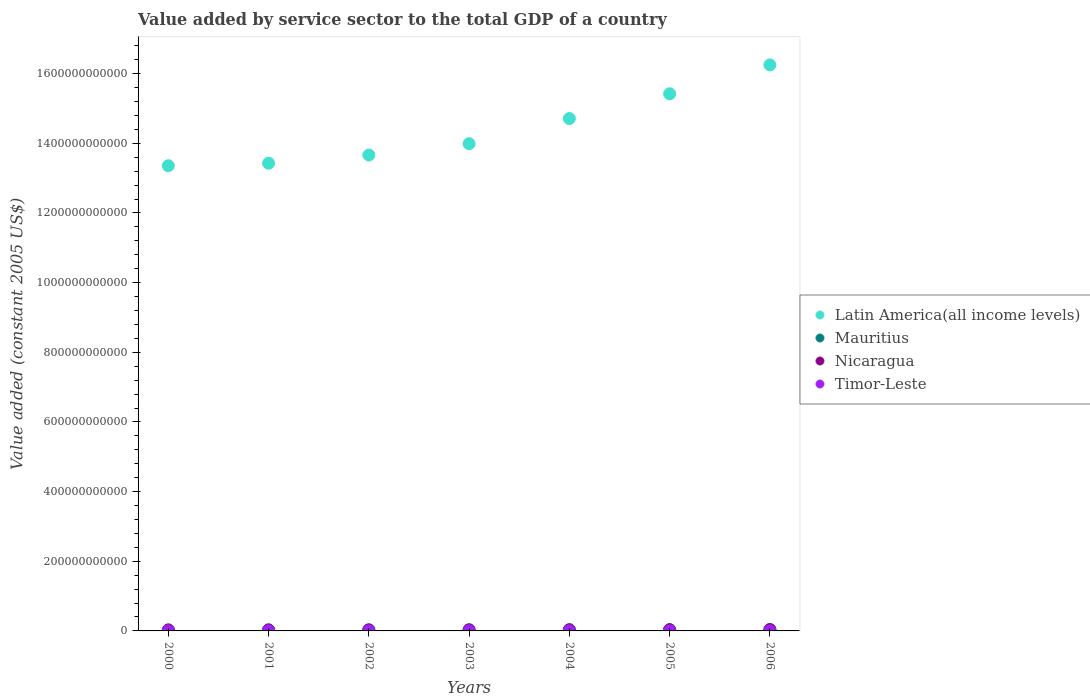How many different coloured dotlines are there?
Ensure brevity in your answer.  4. Is the number of dotlines equal to the number of legend labels?
Your response must be concise. Yes. What is the value added by service sector in Latin America(all income levels) in 2002?
Offer a terse response. 1.37e+12. Across all years, what is the maximum value added by service sector in Mauritius?
Keep it short and to the point. 3.86e+09. Across all years, what is the minimum value added by service sector in Nicaragua?
Offer a very short reply. 2.69e+09. In which year was the value added by service sector in Mauritius maximum?
Make the answer very short. 2006. What is the total value added by service sector in Latin America(all income levels) in the graph?
Your response must be concise. 1.01e+13. What is the difference between the value added by service sector in Mauritius in 2001 and that in 2005?
Ensure brevity in your answer.  -7.43e+08. What is the difference between the value added by service sector in Mauritius in 2003 and the value added by service sector in Latin America(all income levels) in 2005?
Your answer should be compact. -1.54e+12. What is the average value added by service sector in Nicaragua per year?
Make the answer very short. 3.01e+09. In the year 2001, what is the difference between the value added by service sector in Mauritius and value added by service sector in Timor-Leste?
Your answer should be very brief. 2.61e+09. What is the ratio of the value added by service sector in Nicaragua in 2004 to that in 2005?
Ensure brevity in your answer.  0.96. What is the difference between the highest and the second highest value added by service sector in Mauritius?
Offer a very short reply. 2.06e+08. What is the difference between the highest and the lowest value added by service sector in Timor-Leste?
Your answer should be compact. 7.10e+07. In how many years, is the value added by service sector in Latin America(all income levels) greater than the average value added by service sector in Latin America(all income levels) taken over all years?
Your answer should be very brief. 3. Is it the case that in every year, the sum of the value added by service sector in Timor-Leste and value added by service sector in Mauritius  is greater than the sum of value added by service sector in Nicaragua and value added by service sector in Latin America(all income levels)?
Ensure brevity in your answer.  Yes. Is it the case that in every year, the sum of the value added by service sector in Nicaragua and value added by service sector in Mauritius  is greater than the value added by service sector in Timor-Leste?
Ensure brevity in your answer.  Yes. Does the value added by service sector in Latin America(all income levels) monotonically increase over the years?
Make the answer very short. Yes. Is the value added by service sector in Mauritius strictly greater than the value added by service sector in Latin America(all income levels) over the years?
Ensure brevity in your answer.  No. What is the difference between two consecutive major ticks on the Y-axis?
Keep it short and to the point. 2.00e+11. Are the values on the major ticks of Y-axis written in scientific E-notation?
Give a very brief answer. No. Does the graph contain grids?
Provide a short and direct response. No. Where does the legend appear in the graph?
Make the answer very short. Center right. How many legend labels are there?
Offer a terse response. 4. What is the title of the graph?
Provide a short and direct response. Value added by service sector to the total GDP of a country. What is the label or title of the X-axis?
Make the answer very short. Years. What is the label or title of the Y-axis?
Offer a terse response. Value added (constant 2005 US$). What is the Value added (constant 2005 US$) in Latin America(all income levels) in 2000?
Provide a short and direct response. 1.34e+12. What is the Value added (constant 2005 US$) of Mauritius in 2000?
Make the answer very short. 2.77e+09. What is the Value added (constant 2005 US$) of Nicaragua in 2000?
Your response must be concise. 2.69e+09. What is the Value added (constant 2005 US$) in Timor-Leste in 2000?
Offer a terse response. 2.26e+08. What is the Value added (constant 2005 US$) of Latin America(all income levels) in 2001?
Make the answer very short. 1.34e+12. What is the Value added (constant 2005 US$) of Mauritius in 2001?
Give a very brief answer. 2.91e+09. What is the Value added (constant 2005 US$) of Nicaragua in 2001?
Provide a succinct answer. 2.79e+09. What is the Value added (constant 2005 US$) in Timor-Leste in 2001?
Offer a terse response. 2.95e+08. What is the Value added (constant 2005 US$) of Latin America(all income levels) in 2002?
Make the answer very short. 1.37e+12. What is the Value added (constant 2005 US$) of Mauritius in 2002?
Offer a terse response. 3.08e+09. What is the Value added (constant 2005 US$) of Nicaragua in 2002?
Your answer should be very brief. 2.85e+09. What is the Value added (constant 2005 US$) in Timor-Leste in 2002?
Provide a short and direct response. 2.65e+08. What is the Value added (constant 2005 US$) in Latin America(all income levels) in 2003?
Your response must be concise. 1.40e+12. What is the Value added (constant 2005 US$) in Mauritius in 2003?
Ensure brevity in your answer.  3.22e+09. What is the Value added (constant 2005 US$) in Nicaragua in 2003?
Give a very brief answer. 2.95e+09. What is the Value added (constant 2005 US$) in Timor-Leste in 2003?
Ensure brevity in your answer.  2.63e+08. What is the Value added (constant 2005 US$) of Latin America(all income levels) in 2004?
Provide a short and direct response. 1.47e+12. What is the Value added (constant 2005 US$) in Mauritius in 2004?
Your response must be concise. 3.43e+09. What is the Value added (constant 2005 US$) of Nicaragua in 2004?
Offer a terse response. 3.03e+09. What is the Value added (constant 2005 US$) in Timor-Leste in 2004?
Give a very brief answer. 2.73e+08. What is the Value added (constant 2005 US$) of Latin America(all income levels) in 2005?
Give a very brief answer. 1.54e+12. What is the Value added (constant 2005 US$) of Mauritius in 2005?
Provide a succinct answer. 3.65e+09. What is the Value added (constant 2005 US$) of Nicaragua in 2005?
Give a very brief answer. 3.15e+09. What is the Value added (constant 2005 US$) in Timor-Leste in 2005?
Provide a succinct answer. 2.97e+08. What is the Value added (constant 2005 US$) in Latin America(all income levels) in 2006?
Your answer should be very brief. 1.63e+12. What is the Value added (constant 2005 US$) in Mauritius in 2006?
Provide a short and direct response. 3.86e+09. What is the Value added (constant 2005 US$) in Nicaragua in 2006?
Provide a succinct answer. 3.59e+09. What is the Value added (constant 2005 US$) in Timor-Leste in 2006?
Your response must be concise. 2.89e+08. Across all years, what is the maximum Value added (constant 2005 US$) in Latin America(all income levels)?
Provide a short and direct response. 1.63e+12. Across all years, what is the maximum Value added (constant 2005 US$) of Mauritius?
Give a very brief answer. 3.86e+09. Across all years, what is the maximum Value added (constant 2005 US$) in Nicaragua?
Your response must be concise. 3.59e+09. Across all years, what is the maximum Value added (constant 2005 US$) in Timor-Leste?
Give a very brief answer. 2.97e+08. Across all years, what is the minimum Value added (constant 2005 US$) in Latin America(all income levels)?
Make the answer very short. 1.34e+12. Across all years, what is the minimum Value added (constant 2005 US$) of Mauritius?
Offer a very short reply. 2.77e+09. Across all years, what is the minimum Value added (constant 2005 US$) of Nicaragua?
Make the answer very short. 2.69e+09. Across all years, what is the minimum Value added (constant 2005 US$) in Timor-Leste?
Your answer should be compact. 2.26e+08. What is the total Value added (constant 2005 US$) of Latin America(all income levels) in the graph?
Provide a succinct answer. 1.01e+13. What is the total Value added (constant 2005 US$) of Mauritius in the graph?
Offer a very short reply. 2.29e+1. What is the total Value added (constant 2005 US$) in Nicaragua in the graph?
Ensure brevity in your answer.  2.10e+1. What is the total Value added (constant 2005 US$) of Timor-Leste in the graph?
Your response must be concise. 1.91e+09. What is the difference between the Value added (constant 2005 US$) in Latin America(all income levels) in 2000 and that in 2001?
Keep it short and to the point. -7.32e+09. What is the difference between the Value added (constant 2005 US$) of Mauritius in 2000 and that in 2001?
Offer a terse response. -1.40e+08. What is the difference between the Value added (constant 2005 US$) in Nicaragua in 2000 and that in 2001?
Keep it short and to the point. -1.03e+08. What is the difference between the Value added (constant 2005 US$) of Timor-Leste in 2000 and that in 2001?
Ensure brevity in your answer.  -6.95e+07. What is the difference between the Value added (constant 2005 US$) in Latin America(all income levels) in 2000 and that in 2002?
Offer a terse response. -3.07e+1. What is the difference between the Value added (constant 2005 US$) in Mauritius in 2000 and that in 2002?
Ensure brevity in your answer.  -3.16e+08. What is the difference between the Value added (constant 2005 US$) in Nicaragua in 2000 and that in 2002?
Keep it short and to the point. -1.66e+08. What is the difference between the Value added (constant 2005 US$) in Timor-Leste in 2000 and that in 2002?
Your answer should be very brief. -3.89e+07. What is the difference between the Value added (constant 2005 US$) in Latin America(all income levels) in 2000 and that in 2003?
Your response must be concise. -6.33e+1. What is the difference between the Value added (constant 2005 US$) of Mauritius in 2000 and that in 2003?
Provide a succinct answer. -4.56e+08. What is the difference between the Value added (constant 2005 US$) of Nicaragua in 2000 and that in 2003?
Make the answer very short. -2.60e+08. What is the difference between the Value added (constant 2005 US$) in Timor-Leste in 2000 and that in 2003?
Keep it short and to the point. -3.66e+07. What is the difference between the Value added (constant 2005 US$) of Latin America(all income levels) in 2000 and that in 2004?
Offer a very short reply. -1.35e+11. What is the difference between the Value added (constant 2005 US$) in Mauritius in 2000 and that in 2004?
Your answer should be compact. -6.65e+08. What is the difference between the Value added (constant 2005 US$) in Nicaragua in 2000 and that in 2004?
Your answer should be compact. -3.43e+08. What is the difference between the Value added (constant 2005 US$) of Timor-Leste in 2000 and that in 2004?
Offer a very short reply. -4.66e+07. What is the difference between the Value added (constant 2005 US$) of Latin America(all income levels) in 2000 and that in 2005?
Provide a short and direct response. -2.06e+11. What is the difference between the Value added (constant 2005 US$) in Mauritius in 2000 and that in 2005?
Offer a terse response. -8.83e+08. What is the difference between the Value added (constant 2005 US$) in Nicaragua in 2000 and that in 2005?
Provide a short and direct response. -4.63e+08. What is the difference between the Value added (constant 2005 US$) of Timor-Leste in 2000 and that in 2005?
Your answer should be very brief. -7.10e+07. What is the difference between the Value added (constant 2005 US$) of Latin America(all income levels) in 2000 and that in 2006?
Offer a terse response. -2.90e+11. What is the difference between the Value added (constant 2005 US$) in Mauritius in 2000 and that in 2006?
Provide a succinct answer. -1.09e+09. What is the difference between the Value added (constant 2005 US$) in Nicaragua in 2000 and that in 2006?
Provide a short and direct response. -8.97e+08. What is the difference between the Value added (constant 2005 US$) in Timor-Leste in 2000 and that in 2006?
Ensure brevity in your answer.  -6.34e+07. What is the difference between the Value added (constant 2005 US$) of Latin America(all income levels) in 2001 and that in 2002?
Your response must be concise. -2.34e+1. What is the difference between the Value added (constant 2005 US$) in Mauritius in 2001 and that in 2002?
Ensure brevity in your answer.  -1.76e+08. What is the difference between the Value added (constant 2005 US$) of Nicaragua in 2001 and that in 2002?
Provide a short and direct response. -6.33e+07. What is the difference between the Value added (constant 2005 US$) in Timor-Leste in 2001 and that in 2002?
Make the answer very short. 3.05e+07. What is the difference between the Value added (constant 2005 US$) in Latin America(all income levels) in 2001 and that in 2003?
Your answer should be very brief. -5.60e+1. What is the difference between the Value added (constant 2005 US$) in Mauritius in 2001 and that in 2003?
Your response must be concise. -3.15e+08. What is the difference between the Value added (constant 2005 US$) of Nicaragua in 2001 and that in 2003?
Your response must be concise. -1.57e+08. What is the difference between the Value added (constant 2005 US$) in Timor-Leste in 2001 and that in 2003?
Make the answer very short. 3.28e+07. What is the difference between the Value added (constant 2005 US$) in Latin America(all income levels) in 2001 and that in 2004?
Your answer should be compact. -1.28e+11. What is the difference between the Value added (constant 2005 US$) in Mauritius in 2001 and that in 2004?
Ensure brevity in your answer.  -5.25e+08. What is the difference between the Value added (constant 2005 US$) in Nicaragua in 2001 and that in 2004?
Offer a terse response. -2.40e+08. What is the difference between the Value added (constant 2005 US$) of Timor-Leste in 2001 and that in 2004?
Your response must be concise. 2.29e+07. What is the difference between the Value added (constant 2005 US$) in Latin America(all income levels) in 2001 and that in 2005?
Keep it short and to the point. -1.99e+11. What is the difference between the Value added (constant 2005 US$) in Mauritius in 2001 and that in 2005?
Provide a short and direct response. -7.43e+08. What is the difference between the Value added (constant 2005 US$) in Nicaragua in 2001 and that in 2005?
Ensure brevity in your answer.  -3.61e+08. What is the difference between the Value added (constant 2005 US$) of Timor-Leste in 2001 and that in 2005?
Give a very brief answer. -1.53e+06. What is the difference between the Value added (constant 2005 US$) in Latin America(all income levels) in 2001 and that in 2006?
Give a very brief answer. -2.82e+11. What is the difference between the Value added (constant 2005 US$) of Mauritius in 2001 and that in 2006?
Your answer should be very brief. -9.49e+08. What is the difference between the Value added (constant 2005 US$) of Nicaragua in 2001 and that in 2006?
Give a very brief answer. -7.94e+08. What is the difference between the Value added (constant 2005 US$) in Timor-Leste in 2001 and that in 2006?
Give a very brief answer. 6.11e+06. What is the difference between the Value added (constant 2005 US$) of Latin America(all income levels) in 2002 and that in 2003?
Your answer should be very brief. -3.26e+1. What is the difference between the Value added (constant 2005 US$) in Mauritius in 2002 and that in 2003?
Keep it short and to the point. -1.40e+08. What is the difference between the Value added (constant 2005 US$) in Nicaragua in 2002 and that in 2003?
Give a very brief answer. -9.38e+07. What is the difference between the Value added (constant 2005 US$) in Timor-Leste in 2002 and that in 2003?
Provide a succinct answer. 2.29e+06. What is the difference between the Value added (constant 2005 US$) of Latin America(all income levels) in 2002 and that in 2004?
Your response must be concise. -1.05e+11. What is the difference between the Value added (constant 2005 US$) of Mauritius in 2002 and that in 2004?
Offer a terse response. -3.49e+08. What is the difference between the Value added (constant 2005 US$) of Nicaragua in 2002 and that in 2004?
Your answer should be very brief. -1.77e+08. What is the difference between the Value added (constant 2005 US$) in Timor-Leste in 2002 and that in 2004?
Offer a very short reply. -7.63e+06. What is the difference between the Value added (constant 2005 US$) of Latin America(all income levels) in 2002 and that in 2005?
Offer a terse response. -1.76e+11. What is the difference between the Value added (constant 2005 US$) in Mauritius in 2002 and that in 2005?
Offer a very short reply. -5.67e+08. What is the difference between the Value added (constant 2005 US$) of Nicaragua in 2002 and that in 2005?
Keep it short and to the point. -2.97e+08. What is the difference between the Value added (constant 2005 US$) in Timor-Leste in 2002 and that in 2005?
Your answer should be very brief. -3.21e+07. What is the difference between the Value added (constant 2005 US$) of Latin America(all income levels) in 2002 and that in 2006?
Keep it short and to the point. -2.59e+11. What is the difference between the Value added (constant 2005 US$) of Mauritius in 2002 and that in 2006?
Offer a very short reply. -7.73e+08. What is the difference between the Value added (constant 2005 US$) of Nicaragua in 2002 and that in 2006?
Provide a short and direct response. -7.31e+08. What is the difference between the Value added (constant 2005 US$) of Timor-Leste in 2002 and that in 2006?
Offer a terse response. -2.44e+07. What is the difference between the Value added (constant 2005 US$) in Latin America(all income levels) in 2003 and that in 2004?
Offer a terse response. -7.21e+1. What is the difference between the Value added (constant 2005 US$) in Mauritius in 2003 and that in 2004?
Provide a succinct answer. -2.09e+08. What is the difference between the Value added (constant 2005 US$) in Nicaragua in 2003 and that in 2004?
Your response must be concise. -8.30e+07. What is the difference between the Value added (constant 2005 US$) of Timor-Leste in 2003 and that in 2004?
Your answer should be compact. -9.93e+06. What is the difference between the Value added (constant 2005 US$) of Latin America(all income levels) in 2003 and that in 2005?
Give a very brief answer. -1.43e+11. What is the difference between the Value added (constant 2005 US$) of Mauritius in 2003 and that in 2005?
Keep it short and to the point. -4.27e+08. What is the difference between the Value added (constant 2005 US$) of Nicaragua in 2003 and that in 2005?
Provide a short and direct response. -2.04e+08. What is the difference between the Value added (constant 2005 US$) of Timor-Leste in 2003 and that in 2005?
Ensure brevity in your answer.  -3.44e+07. What is the difference between the Value added (constant 2005 US$) of Latin America(all income levels) in 2003 and that in 2006?
Make the answer very short. -2.26e+11. What is the difference between the Value added (constant 2005 US$) of Mauritius in 2003 and that in 2006?
Your answer should be very brief. -6.34e+08. What is the difference between the Value added (constant 2005 US$) of Nicaragua in 2003 and that in 2006?
Keep it short and to the point. -6.37e+08. What is the difference between the Value added (constant 2005 US$) in Timor-Leste in 2003 and that in 2006?
Make the answer very short. -2.67e+07. What is the difference between the Value added (constant 2005 US$) of Latin America(all income levels) in 2004 and that in 2005?
Provide a succinct answer. -7.10e+1. What is the difference between the Value added (constant 2005 US$) in Mauritius in 2004 and that in 2005?
Your answer should be very brief. -2.18e+08. What is the difference between the Value added (constant 2005 US$) of Nicaragua in 2004 and that in 2005?
Give a very brief answer. -1.21e+08. What is the difference between the Value added (constant 2005 US$) of Timor-Leste in 2004 and that in 2005?
Offer a very short reply. -2.44e+07. What is the difference between the Value added (constant 2005 US$) of Latin America(all income levels) in 2004 and that in 2006?
Offer a very short reply. -1.54e+11. What is the difference between the Value added (constant 2005 US$) of Mauritius in 2004 and that in 2006?
Provide a succinct answer. -4.24e+08. What is the difference between the Value added (constant 2005 US$) in Nicaragua in 2004 and that in 2006?
Make the answer very short. -5.54e+08. What is the difference between the Value added (constant 2005 US$) in Timor-Leste in 2004 and that in 2006?
Keep it short and to the point. -1.68e+07. What is the difference between the Value added (constant 2005 US$) in Latin America(all income levels) in 2005 and that in 2006?
Keep it short and to the point. -8.31e+1. What is the difference between the Value added (constant 2005 US$) in Mauritius in 2005 and that in 2006?
Ensure brevity in your answer.  -2.06e+08. What is the difference between the Value added (constant 2005 US$) of Nicaragua in 2005 and that in 2006?
Keep it short and to the point. -4.34e+08. What is the difference between the Value added (constant 2005 US$) in Timor-Leste in 2005 and that in 2006?
Provide a succinct answer. 7.63e+06. What is the difference between the Value added (constant 2005 US$) in Latin America(all income levels) in 2000 and the Value added (constant 2005 US$) in Mauritius in 2001?
Keep it short and to the point. 1.33e+12. What is the difference between the Value added (constant 2005 US$) in Latin America(all income levels) in 2000 and the Value added (constant 2005 US$) in Nicaragua in 2001?
Your answer should be compact. 1.33e+12. What is the difference between the Value added (constant 2005 US$) of Latin America(all income levels) in 2000 and the Value added (constant 2005 US$) of Timor-Leste in 2001?
Ensure brevity in your answer.  1.34e+12. What is the difference between the Value added (constant 2005 US$) of Mauritius in 2000 and the Value added (constant 2005 US$) of Nicaragua in 2001?
Make the answer very short. -2.42e+07. What is the difference between the Value added (constant 2005 US$) of Mauritius in 2000 and the Value added (constant 2005 US$) of Timor-Leste in 2001?
Keep it short and to the point. 2.47e+09. What is the difference between the Value added (constant 2005 US$) of Nicaragua in 2000 and the Value added (constant 2005 US$) of Timor-Leste in 2001?
Offer a very short reply. 2.39e+09. What is the difference between the Value added (constant 2005 US$) of Latin America(all income levels) in 2000 and the Value added (constant 2005 US$) of Mauritius in 2002?
Your answer should be very brief. 1.33e+12. What is the difference between the Value added (constant 2005 US$) in Latin America(all income levels) in 2000 and the Value added (constant 2005 US$) in Nicaragua in 2002?
Ensure brevity in your answer.  1.33e+12. What is the difference between the Value added (constant 2005 US$) of Latin America(all income levels) in 2000 and the Value added (constant 2005 US$) of Timor-Leste in 2002?
Keep it short and to the point. 1.34e+12. What is the difference between the Value added (constant 2005 US$) of Mauritius in 2000 and the Value added (constant 2005 US$) of Nicaragua in 2002?
Provide a succinct answer. -8.75e+07. What is the difference between the Value added (constant 2005 US$) in Mauritius in 2000 and the Value added (constant 2005 US$) in Timor-Leste in 2002?
Provide a short and direct response. 2.50e+09. What is the difference between the Value added (constant 2005 US$) in Nicaragua in 2000 and the Value added (constant 2005 US$) in Timor-Leste in 2002?
Give a very brief answer. 2.42e+09. What is the difference between the Value added (constant 2005 US$) in Latin America(all income levels) in 2000 and the Value added (constant 2005 US$) in Mauritius in 2003?
Make the answer very short. 1.33e+12. What is the difference between the Value added (constant 2005 US$) of Latin America(all income levels) in 2000 and the Value added (constant 2005 US$) of Nicaragua in 2003?
Provide a succinct answer. 1.33e+12. What is the difference between the Value added (constant 2005 US$) in Latin America(all income levels) in 2000 and the Value added (constant 2005 US$) in Timor-Leste in 2003?
Give a very brief answer. 1.34e+12. What is the difference between the Value added (constant 2005 US$) in Mauritius in 2000 and the Value added (constant 2005 US$) in Nicaragua in 2003?
Your answer should be very brief. -1.81e+08. What is the difference between the Value added (constant 2005 US$) in Mauritius in 2000 and the Value added (constant 2005 US$) in Timor-Leste in 2003?
Give a very brief answer. 2.50e+09. What is the difference between the Value added (constant 2005 US$) of Nicaragua in 2000 and the Value added (constant 2005 US$) of Timor-Leste in 2003?
Offer a very short reply. 2.43e+09. What is the difference between the Value added (constant 2005 US$) in Latin America(all income levels) in 2000 and the Value added (constant 2005 US$) in Mauritius in 2004?
Ensure brevity in your answer.  1.33e+12. What is the difference between the Value added (constant 2005 US$) in Latin America(all income levels) in 2000 and the Value added (constant 2005 US$) in Nicaragua in 2004?
Keep it short and to the point. 1.33e+12. What is the difference between the Value added (constant 2005 US$) in Latin America(all income levels) in 2000 and the Value added (constant 2005 US$) in Timor-Leste in 2004?
Your response must be concise. 1.34e+12. What is the difference between the Value added (constant 2005 US$) of Mauritius in 2000 and the Value added (constant 2005 US$) of Nicaragua in 2004?
Ensure brevity in your answer.  -2.64e+08. What is the difference between the Value added (constant 2005 US$) in Mauritius in 2000 and the Value added (constant 2005 US$) in Timor-Leste in 2004?
Ensure brevity in your answer.  2.49e+09. What is the difference between the Value added (constant 2005 US$) in Nicaragua in 2000 and the Value added (constant 2005 US$) in Timor-Leste in 2004?
Offer a very short reply. 2.42e+09. What is the difference between the Value added (constant 2005 US$) in Latin America(all income levels) in 2000 and the Value added (constant 2005 US$) in Mauritius in 2005?
Your response must be concise. 1.33e+12. What is the difference between the Value added (constant 2005 US$) in Latin America(all income levels) in 2000 and the Value added (constant 2005 US$) in Nicaragua in 2005?
Offer a terse response. 1.33e+12. What is the difference between the Value added (constant 2005 US$) of Latin America(all income levels) in 2000 and the Value added (constant 2005 US$) of Timor-Leste in 2005?
Keep it short and to the point. 1.34e+12. What is the difference between the Value added (constant 2005 US$) of Mauritius in 2000 and the Value added (constant 2005 US$) of Nicaragua in 2005?
Offer a terse response. -3.85e+08. What is the difference between the Value added (constant 2005 US$) in Mauritius in 2000 and the Value added (constant 2005 US$) in Timor-Leste in 2005?
Offer a very short reply. 2.47e+09. What is the difference between the Value added (constant 2005 US$) of Nicaragua in 2000 and the Value added (constant 2005 US$) of Timor-Leste in 2005?
Your answer should be very brief. 2.39e+09. What is the difference between the Value added (constant 2005 US$) in Latin America(all income levels) in 2000 and the Value added (constant 2005 US$) in Mauritius in 2006?
Provide a succinct answer. 1.33e+12. What is the difference between the Value added (constant 2005 US$) of Latin America(all income levels) in 2000 and the Value added (constant 2005 US$) of Nicaragua in 2006?
Your response must be concise. 1.33e+12. What is the difference between the Value added (constant 2005 US$) of Latin America(all income levels) in 2000 and the Value added (constant 2005 US$) of Timor-Leste in 2006?
Your response must be concise. 1.34e+12. What is the difference between the Value added (constant 2005 US$) of Mauritius in 2000 and the Value added (constant 2005 US$) of Nicaragua in 2006?
Your response must be concise. -8.18e+08. What is the difference between the Value added (constant 2005 US$) in Mauritius in 2000 and the Value added (constant 2005 US$) in Timor-Leste in 2006?
Offer a terse response. 2.48e+09. What is the difference between the Value added (constant 2005 US$) in Nicaragua in 2000 and the Value added (constant 2005 US$) in Timor-Leste in 2006?
Make the answer very short. 2.40e+09. What is the difference between the Value added (constant 2005 US$) of Latin America(all income levels) in 2001 and the Value added (constant 2005 US$) of Mauritius in 2002?
Provide a short and direct response. 1.34e+12. What is the difference between the Value added (constant 2005 US$) in Latin America(all income levels) in 2001 and the Value added (constant 2005 US$) in Nicaragua in 2002?
Offer a very short reply. 1.34e+12. What is the difference between the Value added (constant 2005 US$) of Latin America(all income levels) in 2001 and the Value added (constant 2005 US$) of Timor-Leste in 2002?
Give a very brief answer. 1.34e+12. What is the difference between the Value added (constant 2005 US$) in Mauritius in 2001 and the Value added (constant 2005 US$) in Nicaragua in 2002?
Your response must be concise. 5.27e+07. What is the difference between the Value added (constant 2005 US$) in Mauritius in 2001 and the Value added (constant 2005 US$) in Timor-Leste in 2002?
Your response must be concise. 2.64e+09. What is the difference between the Value added (constant 2005 US$) of Nicaragua in 2001 and the Value added (constant 2005 US$) of Timor-Leste in 2002?
Your answer should be compact. 2.53e+09. What is the difference between the Value added (constant 2005 US$) in Latin America(all income levels) in 2001 and the Value added (constant 2005 US$) in Mauritius in 2003?
Your answer should be compact. 1.34e+12. What is the difference between the Value added (constant 2005 US$) of Latin America(all income levels) in 2001 and the Value added (constant 2005 US$) of Nicaragua in 2003?
Make the answer very short. 1.34e+12. What is the difference between the Value added (constant 2005 US$) of Latin America(all income levels) in 2001 and the Value added (constant 2005 US$) of Timor-Leste in 2003?
Keep it short and to the point. 1.34e+12. What is the difference between the Value added (constant 2005 US$) in Mauritius in 2001 and the Value added (constant 2005 US$) in Nicaragua in 2003?
Your answer should be very brief. -4.11e+07. What is the difference between the Value added (constant 2005 US$) of Mauritius in 2001 and the Value added (constant 2005 US$) of Timor-Leste in 2003?
Give a very brief answer. 2.64e+09. What is the difference between the Value added (constant 2005 US$) in Nicaragua in 2001 and the Value added (constant 2005 US$) in Timor-Leste in 2003?
Offer a very short reply. 2.53e+09. What is the difference between the Value added (constant 2005 US$) in Latin America(all income levels) in 2001 and the Value added (constant 2005 US$) in Mauritius in 2004?
Keep it short and to the point. 1.34e+12. What is the difference between the Value added (constant 2005 US$) in Latin America(all income levels) in 2001 and the Value added (constant 2005 US$) in Nicaragua in 2004?
Provide a short and direct response. 1.34e+12. What is the difference between the Value added (constant 2005 US$) of Latin America(all income levels) in 2001 and the Value added (constant 2005 US$) of Timor-Leste in 2004?
Provide a succinct answer. 1.34e+12. What is the difference between the Value added (constant 2005 US$) of Mauritius in 2001 and the Value added (constant 2005 US$) of Nicaragua in 2004?
Your answer should be compact. -1.24e+08. What is the difference between the Value added (constant 2005 US$) in Mauritius in 2001 and the Value added (constant 2005 US$) in Timor-Leste in 2004?
Give a very brief answer. 2.63e+09. What is the difference between the Value added (constant 2005 US$) of Nicaragua in 2001 and the Value added (constant 2005 US$) of Timor-Leste in 2004?
Offer a terse response. 2.52e+09. What is the difference between the Value added (constant 2005 US$) of Latin America(all income levels) in 2001 and the Value added (constant 2005 US$) of Mauritius in 2005?
Ensure brevity in your answer.  1.34e+12. What is the difference between the Value added (constant 2005 US$) of Latin America(all income levels) in 2001 and the Value added (constant 2005 US$) of Nicaragua in 2005?
Provide a succinct answer. 1.34e+12. What is the difference between the Value added (constant 2005 US$) of Latin America(all income levels) in 2001 and the Value added (constant 2005 US$) of Timor-Leste in 2005?
Provide a succinct answer. 1.34e+12. What is the difference between the Value added (constant 2005 US$) of Mauritius in 2001 and the Value added (constant 2005 US$) of Nicaragua in 2005?
Give a very brief answer. -2.45e+08. What is the difference between the Value added (constant 2005 US$) of Mauritius in 2001 and the Value added (constant 2005 US$) of Timor-Leste in 2005?
Ensure brevity in your answer.  2.61e+09. What is the difference between the Value added (constant 2005 US$) of Nicaragua in 2001 and the Value added (constant 2005 US$) of Timor-Leste in 2005?
Make the answer very short. 2.49e+09. What is the difference between the Value added (constant 2005 US$) of Latin America(all income levels) in 2001 and the Value added (constant 2005 US$) of Mauritius in 2006?
Ensure brevity in your answer.  1.34e+12. What is the difference between the Value added (constant 2005 US$) of Latin America(all income levels) in 2001 and the Value added (constant 2005 US$) of Nicaragua in 2006?
Keep it short and to the point. 1.34e+12. What is the difference between the Value added (constant 2005 US$) of Latin America(all income levels) in 2001 and the Value added (constant 2005 US$) of Timor-Leste in 2006?
Your answer should be compact. 1.34e+12. What is the difference between the Value added (constant 2005 US$) of Mauritius in 2001 and the Value added (constant 2005 US$) of Nicaragua in 2006?
Make the answer very short. -6.78e+08. What is the difference between the Value added (constant 2005 US$) of Mauritius in 2001 and the Value added (constant 2005 US$) of Timor-Leste in 2006?
Offer a very short reply. 2.62e+09. What is the difference between the Value added (constant 2005 US$) of Nicaragua in 2001 and the Value added (constant 2005 US$) of Timor-Leste in 2006?
Offer a very short reply. 2.50e+09. What is the difference between the Value added (constant 2005 US$) of Latin America(all income levels) in 2002 and the Value added (constant 2005 US$) of Mauritius in 2003?
Offer a very short reply. 1.36e+12. What is the difference between the Value added (constant 2005 US$) of Latin America(all income levels) in 2002 and the Value added (constant 2005 US$) of Nicaragua in 2003?
Provide a succinct answer. 1.36e+12. What is the difference between the Value added (constant 2005 US$) of Latin America(all income levels) in 2002 and the Value added (constant 2005 US$) of Timor-Leste in 2003?
Your answer should be very brief. 1.37e+12. What is the difference between the Value added (constant 2005 US$) in Mauritius in 2002 and the Value added (constant 2005 US$) in Nicaragua in 2003?
Provide a succinct answer. 1.34e+08. What is the difference between the Value added (constant 2005 US$) in Mauritius in 2002 and the Value added (constant 2005 US$) in Timor-Leste in 2003?
Offer a very short reply. 2.82e+09. What is the difference between the Value added (constant 2005 US$) in Nicaragua in 2002 and the Value added (constant 2005 US$) in Timor-Leste in 2003?
Keep it short and to the point. 2.59e+09. What is the difference between the Value added (constant 2005 US$) of Latin America(all income levels) in 2002 and the Value added (constant 2005 US$) of Mauritius in 2004?
Ensure brevity in your answer.  1.36e+12. What is the difference between the Value added (constant 2005 US$) of Latin America(all income levels) in 2002 and the Value added (constant 2005 US$) of Nicaragua in 2004?
Offer a very short reply. 1.36e+12. What is the difference between the Value added (constant 2005 US$) of Latin America(all income levels) in 2002 and the Value added (constant 2005 US$) of Timor-Leste in 2004?
Offer a terse response. 1.37e+12. What is the difference between the Value added (constant 2005 US$) in Mauritius in 2002 and the Value added (constant 2005 US$) in Nicaragua in 2004?
Give a very brief answer. 5.14e+07. What is the difference between the Value added (constant 2005 US$) in Mauritius in 2002 and the Value added (constant 2005 US$) in Timor-Leste in 2004?
Your answer should be very brief. 2.81e+09. What is the difference between the Value added (constant 2005 US$) of Nicaragua in 2002 and the Value added (constant 2005 US$) of Timor-Leste in 2004?
Offer a terse response. 2.58e+09. What is the difference between the Value added (constant 2005 US$) of Latin America(all income levels) in 2002 and the Value added (constant 2005 US$) of Mauritius in 2005?
Keep it short and to the point. 1.36e+12. What is the difference between the Value added (constant 2005 US$) in Latin America(all income levels) in 2002 and the Value added (constant 2005 US$) in Nicaragua in 2005?
Provide a succinct answer. 1.36e+12. What is the difference between the Value added (constant 2005 US$) in Latin America(all income levels) in 2002 and the Value added (constant 2005 US$) in Timor-Leste in 2005?
Offer a very short reply. 1.37e+12. What is the difference between the Value added (constant 2005 US$) of Mauritius in 2002 and the Value added (constant 2005 US$) of Nicaragua in 2005?
Make the answer very short. -6.91e+07. What is the difference between the Value added (constant 2005 US$) in Mauritius in 2002 and the Value added (constant 2005 US$) in Timor-Leste in 2005?
Offer a very short reply. 2.79e+09. What is the difference between the Value added (constant 2005 US$) in Nicaragua in 2002 and the Value added (constant 2005 US$) in Timor-Leste in 2005?
Offer a terse response. 2.56e+09. What is the difference between the Value added (constant 2005 US$) in Latin America(all income levels) in 2002 and the Value added (constant 2005 US$) in Mauritius in 2006?
Your response must be concise. 1.36e+12. What is the difference between the Value added (constant 2005 US$) in Latin America(all income levels) in 2002 and the Value added (constant 2005 US$) in Nicaragua in 2006?
Keep it short and to the point. 1.36e+12. What is the difference between the Value added (constant 2005 US$) in Latin America(all income levels) in 2002 and the Value added (constant 2005 US$) in Timor-Leste in 2006?
Keep it short and to the point. 1.37e+12. What is the difference between the Value added (constant 2005 US$) in Mauritius in 2002 and the Value added (constant 2005 US$) in Nicaragua in 2006?
Provide a succinct answer. -5.03e+08. What is the difference between the Value added (constant 2005 US$) of Mauritius in 2002 and the Value added (constant 2005 US$) of Timor-Leste in 2006?
Keep it short and to the point. 2.79e+09. What is the difference between the Value added (constant 2005 US$) of Nicaragua in 2002 and the Value added (constant 2005 US$) of Timor-Leste in 2006?
Offer a terse response. 2.56e+09. What is the difference between the Value added (constant 2005 US$) in Latin America(all income levels) in 2003 and the Value added (constant 2005 US$) in Mauritius in 2004?
Ensure brevity in your answer.  1.40e+12. What is the difference between the Value added (constant 2005 US$) of Latin America(all income levels) in 2003 and the Value added (constant 2005 US$) of Nicaragua in 2004?
Offer a very short reply. 1.40e+12. What is the difference between the Value added (constant 2005 US$) of Latin America(all income levels) in 2003 and the Value added (constant 2005 US$) of Timor-Leste in 2004?
Offer a terse response. 1.40e+12. What is the difference between the Value added (constant 2005 US$) of Mauritius in 2003 and the Value added (constant 2005 US$) of Nicaragua in 2004?
Your answer should be very brief. 1.91e+08. What is the difference between the Value added (constant 2005 US$) in Mauritius in 2003 and the Value added (constant 2005 US$) in Timor-Leste in 2004?
Offer a terse response. 2.95e+09. What is the difference between the Value added (constant 2005 US$) in Nicaragua in 2003 and the Value added (constant 2005 US$) in Timor-Leste in 2004?
Keep it short and to the point. 2.68e+09. What is the difference between the Value added (constant 2005 US$) in Latin America(all income levels) in 2003 and the Value added (constant 2005 US$) in Mauritius in 2005?
Offer a very short reply. 1.40e+12. What is the difference between the Value added (constant 2005 US$) of Latin America(all income levels) in 2003 and the Value added (constant 2005 US$) of Nicaragua in 2005?
Provide a succinct answer. 1.40e+12. What is the difference between the Value added (constant 2005 US$) of Latin America(all income levels) in 2003 and the Value added (constant 2005 US$) of Timor-Leste in 2005?
Your answer should be compact. 1.40e+12. What is the difference between the Value added (constant 2005 US$) of Mauritius in 2003 and the Value added (constant 2005 US$) of Nicaragua in 2005?
Your answer should be very brief. 7.08e+07. What is the difference between the Value added (constant 2005 US$) in Mauritius in 2003 and the Value added (constant 2005 US$) in Timor-Leste in 2005?
Keep it short and to the point. 2.93e+09. What is the difference between the Value added (constant 2005 US$) in Nicaragua in 2003 and the Value added (constant 2005 US$) in Timor-Leste in 2005?
Make the answer very short. 2.65e+09. What is the difference between the Value added (constant 2005 US$) of Latin America(all income levels) in 2003 and the Value added (constant 2005 US$) of Mauritius in 2006?
Provide a succinct answer. 1.40e+12. What is the difference between the Value added (constant 2005 US$) of Latin America(all income levels) in 2003 and the Value added (constant 2005 US$) of Nicaragua in 2006?
Keep it short and to the point. 1.40e+12. What is the difference between the Value added (constant 2005 US$) in Latin America(all income levels) in 2003 and the Value added (constant 2005 US$) in Timor-Leste in 2006?
Ensure brevity in your answer.  1.40e+12. What is the difference between the Value added (constant 2005 US$) in Mauritius in 2003 and the Value added (constant 2005 US$) in Nicaragua in 2006?
Ensure brevity in your answer.  -3.63e+08. What is the difference between the Value added (constant 2005 US$) of Mauritius in 2003 and the Value added (constant 2005 US$) of Timor-Leste in 2006?
Give a very brief answer. 2.93e+09. What is the difference between the Value added (constant 2005 US$) in Nicaragua in 2003 and the Value added (constant 2005 US$) in Timor-Leste in 2006?
Provide a short and direct response. 2.66e+09. What is the difference between the Value added (constant 2005 US$) in Latin America(all income levels) in 2004 and the Value added (constant 2005 US$) in Mauritius in 2005?
Make the answer very short. 1.47e+12. What is the difference between the Value added (constant 2005 US$) of Latin America(all income levels) in 2004 and the Value added (constant 2005 US$) of Nicaragua in 2005?
Your answer should be very brief. 1.47e+12. What is the difference between the Value added (constant 2005 US$) of Latin America(all income levels) in 2004 and the Value added (constant 2005 US$) of Timor-Leste in 2005?
Make the answer very short. 1.47e+12. What is the difference between the Value added (constant 2005 US$) of Mauritius in 2004 and the Value added (constant 2005 US$) of Nicaragua in 2005?
Your response must be concise. 2.80e+08. What is the difference between the Value added (constant 2005 US$) in Mauritius in 2004 and the Value added (constant 2005 US$) in Timor-Leste in 2005?
Provide a short and direct response. 3.13e+09. What is the difference between the Value added (constant 2005 US$) of Nicaragua in 2004 and the Value added (constant 2005 US$) of Timor-Leste in 2005?
Your answer should be very brief. 2.73e+09. What is the difference between the Value added (constant 2005 US$) of Latin America(all income levels) in 2004 and the Value added (constant 2005 US$) of Mauritius in 2006?
Ensure brevity in your answer.  1.47e+12. What is the difference between the Value added (constant 2005 US$) in Latin America(all income levels) in 2004 and the Value added (constant 2005 US$) in Nicaragua in 2006?
Your answer should be very brief. 1.47e+12. What is the difference between the Value added (constant 2005 US$) of Latin America(all income levels) in 2004 and the Value added (constant 2005 US$) of Timor-Leste in 2006?
Offer a terse response. 1.47e+12. What is the difference between the Value added (constant 2005 US$) in Mauritius in 2004 and the Value added (constant 2005 US$) in Nicaragua in 2006?
Offer a terse response. -1.53e+08. What is the difference between the Value added (constant 2005 US$) of Mauritius in 2004 and the Value added (constant 2005 US$) of Timor-Leste in 2006?
Your answer should be compact. 3.14e+09. What is the difference between the Value added (constant 2005 US$) in Nicaragua in 2004 and the Value added (constant 2005 US$) in Timor-Leste in 2006?
Provide a succinct answer. 2.74e+09. What is the difference between the Value added (constant 2005 US$) of Latin America(all income levels) in 2005 and the Value added (constant 2005 US$) of Mauritius in 2006?
Give a very brief answer. 1.54e+12. What is the difference between the Value added (constant 2005 US$) in Latin America(all income levels) in 2005 and the Value added (constant 2005 US$) in Nicaragua in 2006?
Offer a very short reply. 1.54e+12. What is the difference between the Value added (constant 2005 US$) of Latin America(all income levels) in 2005 and the Value added (constant 2005 US$) of Timor-Leste in 2006?
Your answer should be compact. 1.54e+12. What is the difference between the Value added (constant 2005 US$) in Mauritius in 2005 and the Value added (constant 2005 US$) in Nicaragua in 2006?
Offer a very short reply. 6.44e+07. What is the difference between the Value added (constant 2005 US$) in Mauritius in 2005 and the Value added (constant 2005 US$) in Timor-Leste in 2006?
Make the answer very short. 3.36e+09. What is the difference between the Value added (constant 2005 US$) in Nicaragua in 2005 and the Value added (constant 2005 US$) in Timor-Leste in 2006?
Ensure brevity in your answer.  2.86e+09. What is the average Value added (constant 2005 US$) of Latin America(all income levels) per year?
Your response must be concise. 1.44e+12. What is the average Value added (constant 2005 US$) of Mauritius per year?
Offer a terse response. 3.27e+09. What is the average Value added (constant 2005 US$) in Nicaragua per year?
Keep it short and to the point. 3.01e+09. What is the average Value added (constant 2005 US$) of Timor-Leste per year?
Make the answer very short. 2.73e+08. In the year 2000, what is the difference between the Value added (constant 2005 US$) of Latin America(all income levels) and Value added (constant 2005 US$) of Mauritius?
Give a very brief answer. 1.33e+12. In the year 2000, what is the difference between the Value added (constant 2005 US$) in Latin America(all income levels) and Value added (constant 2005 US$) in Nicaragua?
Keep it short and to the point. 1.33e+12. In the year 2000, what is the difference between the Value added (constant 2005 US$) of Latin America(all income levels) and Value added (constant 2005 US$) of Timor-Leste?
Offer a terse response. 1.34e+12. In the year 2000, what is the difference between the Value added (constant 2005 US$) of Mauritius and Value added (constant 2005 US$) of Nicaragua?
Your answer should be very brief. 7.87e+07. In the year 2000, what is the difference between the Value added (constant 2005 US$) in Mauritius and Value added (constant 2005 US$) in Timor-Leste?
Ensure brevity in your answer.  2.54e+09. In the year 2000, what is the difference between the Value added (constant 2005 US$) in Nicaragua and Value added (constant 2005 US$) in Timor-Leste?
Keep it short and to the point. 2.46e+09. In the year 2001, what is the difference between the Value added (constant 2005 US$) of Latin America(all income levels) and Value added (constant 2005 US$) of Mauritius?
Provide a short and direct response. 1.34e+12. In the year 2001, what is the difference between the Value added (constant 2005 US$) of Latin America(all income levels) and Value added (constant 2005 US$) of Nicaragua?
Offer a terse response. 1.34e+12. In the year 2001, what is the difference between the Value added (constant 2005 US$) in Latin America(all income levels) and Value added (constant 2005 US$) in Timor-Leste?
Provide a succinct answer. 1.34e+12. In the year 2001, what is the difference between the Value added (constant 2005 US$) in Mauritius and Value added (constant 2005 US$) in Nicaragua?
Your answer should be compact. 1.16e+08. In the year 2001, what is the difference between the Value added (constant 2005 US$) in Mauritius and Value added (constant 2005 US$) in Timor-Leste?
Keep it short and to the point. 2.61e+09. In the year 2001, what is the difference between the Value added (constant 2005 US$) in Nicaragua and Value added (constant 2005 US$) in Timor-Leste?
Offer a terse response. 2.50e+09. In the year 2002, what is the difference between the Value added (constant 2005 US$) of Latin America(all income levels) and Value added (constant 2005 US$) of Mauritius?
Your response must be concise. 1.36e+12. In the year 2002, what is the difference between the Value added (constant 2005 US$) of Latin America(all income levels) and Value added (constant 2005 US$) of Nicaragua?
Make the answer very short. 1.36e+12. In the year 2002, what is the difference between the Value added (constant 2005 US$) in Latin America(all income levels) and Value added (constant 2005 US$) in Timor-Leste?
Ensure brevity in your answer.  1.37e+12. In the year 2002, what is the difference between the Value added (constant 2005 US$) of Mauritius and Value added (constant 2005 US$) of Nicaragua?
Make the answer very short. 2.28e+08. In the year 2002, what is the difference between the Value added (constant 2005 US$) in Mauritius and Value added (constant 2005 US$) in Timor-Leste?
Keep it short and to the point. 2.82e+09. In the year 2002, what is the difference between the Value added (constant 2005 US$) in Nicaragua and Value added (constant 2005 US$) in Timor-Leste?
Your answer should be compact. 2.59e+09. In the year 2003, what is the difference between the Value added (constant 2005 US$) in Latin America(all income levels) and Value added (constant 2005 US$) in Mauritius?
Offer a very short reply. 1.40e+12. In the year 2003, what is the difference between the Value added (constant 2005 US$) of Latin America(all income levels) and Value added (constant 2005 US$) of Nicaragua?
Provide a short and direct response. 1.40e+12. In the year 2003, what is the difference between the Value added (constant 2005 US$) in Latin America(all income levels) and Value added (constant 2005 US$) in Timor-Leste?
Keep it short and to the point. 1.40e+12. In the year 2003, what is the difference between the Value added (constant 2005 US$) in Mauritius and Value added (constant 2005 US$) in Nicaragua?
Make the answer very short. 2.74e+08. In the year 2003, what is the difference between the Value added (constant 2005 US$) in Mauritius and Value added (constant 2005 US$) in Timor-Leste?
Offer a terse response. 2.96e+09. In the year 2003, what is the difference between the Value added (constant 2005 US$) in Nicaragua and Value added (constant 2005 US$) in Timor-Leste?
Give a very brief answer. 2.69e+09. In the year 2004, what is the difference between the Value added (constant 2005 US$) of Latin America(all income levels) and Value added (constant 2005 US$) of Mauritius?
Your response must be concise. 1.47e+12. In the year 2004, what is the difference between the Value added (constant 2005 US$) in Latin America(all income levels) and Value added (constant 2005 US$) in Nicaragua?
Offer a very short reply. 1.47e+12. In the year 2004, what is the difference between the Value added (constant 2005 US$) of Latin America(all income levels) and Value added (constant 2005 US$) of Timor-Leste?
Your response must be concise. 1.47e+12. In the year 2004, what is the difference between the Value added (constant 2005 US$) in Mauritius and Value added (constant 2005 US$) in Nicaragua?
Your answer should be very brief. 4.01e+08. In the year 2004, what is the difference between the Value added (constant 2005 US$) of Mauritius and Value added (constant 2005 US$) of Timor-Leste?
Keep it short and to the point. 3.16e+09. In the year 2004, what is the difference between the Value added (constant 2005 US$) in Nicaragua and Value added (constant 2005 US$) in Timor-Leste?
Provide a short and direct response. 2.76e+09. In the year 2005, what is the difference between the Value added (constant 2005 US$) of Latin America(all income levels) and Value added (constant 2005 US$) of Mauritius?
Your response must be concise. 1.54e+12. In the year 2005, what is the difference between the Value added (constant 2005 US$) in Latin America(all income levels) and Value added (constant 2005 US$) in Nicaragua?
Your answer should be compact. 1.54e+12. In the year 2005, what is the difference between the Value added (constant 2005 US$) of Latin America(all income levels) and Value added (constant 2005 US$) of Timor-Leste?
Give a very brief answer. 1.54e+12. In the year 2005, what is the difference between the Value added (constant 2005 US$) of Mauritius and Value added (constant 2005 US$) of Nicaragua?
Your answer should be compact. 4.98e+08. In the year 2005, what is the difference between the Value added (constant 2005 US$) of Mauritius and Value added (constant 2005 US$) of Timor-Leste?
Provide a short and direct response. 3.35e+09. In the year 2005, what is the difference between the Value added (constant 2005 US$) in Nicaragua and Value added (constant 2005 US$) in Timor-Leste?
Your answer should be compact. 2.85e+09. In the year 2006, what is the difference between the Value added (constant 2005 US$) in Latin America(all income levels) and Value added (constant 2005 US$) in Mauritius?
Offer a terse response. 1.62e+12. In the year 2006, what is the difference between the Value added (constant 2005 US$) of Latin America(all income levels) and Value added (constant 2005 US$) of Nicaragua?
Make the answer very short. 1.62e+12. In the year 2006, what is the difference between the Value added (constant 2005 US$) in Latin America(all income levels) and Value added (constant 2005 US$) in Timor-Leste?
Provide a short and direct response. 1.62e+12. In the year 2006, what is the difference between the Value added (constant 2005 US$) in Mauritius and Value added (constant 2005 US$) in Nicaragua?
Your answer should be very brief. 2.71e+08. In the year 2006, what is the difference between the Value added (constant 2005 US$) of Mauritius and Value added (constant 2005 US$) of Timor-Leste?
Ensure brevity in your answer.  3.57e+09. In the year 2006, what is the difference between the Value added (constant 2005 US$) in Nicaragua and Value added (constant 2005 US$) in Timor-Leste?
Offer a very short reply. 3.30e+09. What is the ratio of the Value added (constant 2005 US$) of Mauritius in 2000 to that in 2001?
Give a very brief answer. 0.95. What is the ratio of the Value added (constant 2005 US$) in Nicaragua in 2000 to that in 2001?
Your answer should be compact. 0.96. What is the ratio of the Value added (constant 2005 US$) in Timor-Leste in 2000 to that in 2001?
Offer a terse response. 0.76. What is the ratio of the Value added (constant 2005 US$) in Latin America(all income levels) in 2000 to that in 2002?
Your answer should be very brief. 0.98. What is the ratio of the Value added (constant 2005 US$) in Mauritius in 2000 to that in 2002?
Keep it short and to the point. 0.9. What is the ratio of the Value added (constant 2005 US$) of Nicaragua in 2000 to that in 2002?
Give a very brief answer. 0.94. What is the ratio of the Value added (constant 2005 US$) in Timor-Leste in 2000 to that in 2002?
Give a very brief answer. 0.85. What is the ratio of the Value added (constant 2005 US$) of Latin America(all income levels) in 2000 to that in 2003?
Offer a very short reply. 0.95. What is the ratio of the Value added (constant 2005 US$) in Mauritius in 2000 to that in 2003?
Your answer should be compact. 0.86. What is the ratio of the Value added (constant 2005 US$) in Nicaragua in 2000 to that in 2003?
Provide a succinct answer. 0.91. What is the ratio of the Value added (constant 2005 US$) in Timor-Leste in 2000 to that in 2003?
Give a very brief answer. 0.86. What is the ratio of the Value added (constant 2005 US$) of Latin America(all income levels) in 2000 to that in 2004?
Give a very brief answer. 0.91. What is the ratio of the Value added (constant 2005 US$) of Mauritius in 2000 to that in 2004?
Your answer should be very brief. 0.81. What is the ratio of the Value added (constant 2005 US$) in Nicaragua in 2000 to that in 2004?
Ensure brevity in your answer.  0.89. What is the ratio of the Value added (constant 2005 US$) of Timor-Leste in 2000 to that in 2004?
Provide a short and direct response. 0.83. What is the ratio of the Value added (constant 2005 US$) in Latin America(all income levels) in 2000 to that in 2005?
Make the answer very short. 0.87. What is the ratio of the Value added (constant 2005 US$) in Mauritius in 2000 to that in 2005?
Your answer should be very brief. 0.76. What is the ratio of the Value added (constant 2005 US$) of Nicaragua in 2000 to that in 2005?
Provide a succinct answer. 0.85. What is the ratio of the Value added (constant 2005 US$) in Timor-Leste in 2000 to that in 2005?
Offer a very short reply. 0.76. What is the ratio of the Value added (constant 2005 US$) of Latin America(all income levels) in 2000 to that in 2006?
Provide a succinct answer. 0.82. What is the ratio of the Value added (constant 2005 US$) in Mauritius in 2000 to that in 2006?
Your answer should be very brief. 0.72. What is the ratio of the Value added (constant 2005 US$) of Nicaragua in 2000 to that in 2006?
Your answer should be very brief. 0.75. What is the ratio of the Value added (constant 2005 US$) of Timor-Leste in 2000 to that in 2006?
Give a very brief answer. 0.78. What is the ratio of the Value added (constant 2005 US$) in Latin America(all income levels) in 2001 to that in 2002?
Your answer should be very brief. 0.98. What is the ratio of the Value added (constant 2005 US$) in Mauritius in 2001 to that in 2002?
Your answer should be compact. 0.94. What is the ratio of the Value added (constant 2005 US$) of Nicaragua in 2001 to that in 2002?
Provide a short and direct response. 0.98. What is the ratio of the Value added (constant 2005 US$) in Timor-Leste in 2001 to that in 2002?
Offer a very short reply. 1.12. What is the ratio of the Value added (constant 2005 US$) in Mauritius in 2001 to that in 2003?
Your response must be concise. 0.9. What is the ratio of the Value added (constant 2005 US$) in Nicaragua in 2001 to that in 2003?
Make the answer very short. 0.95. What is the ratio of the Value added (constant 2005 US$) in Timor-Leste in 2001 to that in 2003?
Your response must be concise. 1.12. What is the ratio of the Value added (constant 2005 US$) in Latin America(all income levels) in 2001 to that in 2004?
Give a very brief answer. 0.91. What is the ratio of the Value added (constant 2005 US$) in Mauritius in 2001 to that in 2004?
Give a very brief answer. 0.85. What is the ratio of the Value added (constant 2005 US$) in Nicaragua in 2001 to that in 2004?
Your response must be concise. 0.92. What is the ratio of the Value added (constant 2005 US$) in Timor-Leste in 2001 to that in 2004?
Provide a succinct answer. 1.08. What is the ratio of the Value added (constant 2005 US$) of Latin America(all income levels) in 2001 to that in 2005?
Provide a succinct answer. 0.87. What is the ratio of the Value added (constant 2005 US$) of Mauritius in 2001 to that in 2005?
Your answer should be compact. 0.8. What is the ratio of the Value added (constant 2005 US$) of Nicaragua in 2001 to that in 2005?
Ensure brevity in your answer.  0.89. What is the ratio of the Value added (constant 2005 US$) of Latin America(all income levels) in 2001 to that in 2006?
Provide a short and direct response. 0.83. What is the ratio of the Value added (constant 2005 US$) in Mauritius in 2001 to that in 2006?
Provide a short and direct response. 0.75. What is the ratio of the Value added (constant 2005 US$) of Nicaragua in 2001 to that in 2006?
Your answer should be very brief. 0.78. What is the ratio of the Value added (constant 2005 US$) of Timor-Leste in 2001 to that in 2006?
Provide a succinct answer. 1.02. What is the ratio of the Value added (constant 2005 US$) of Latin America(all income levels) in 2002 to that in 2003?
Your response must be concise. 0.98. What is the ratio of the Value added (constant 2005 US$) in Mauritius in 2002 to that in 2003?
Your answer should be very brief. 0.96. What is the ratio of the Value added (constant 2005 US$) of Nicaragua in 2002 to that in 2003?
Your answer should be compact. 0.97. What is the ratio of the Value added (constant 2005 US$) of Timor-Leste in 2002 to that in 2003?
Offer a terse response. 1.01. What is the ratio of the Value added (constant 2005 US$) of Latin America(all income levels) in 2002 to that in 2004?
Provide a succinct answer. 0.93. What is the ratio of the Value added (constant 2005 US$) in Mauritius in 2002 to that in 2004?
Keep it short and to the point. 0.9. What is the ratio of the Value added (constant 2005 US$) of Nicaragua in 2002 to that in 2004?
Provide a short and direct response. 0.94. What is the ratio of the Value added (constant 2005 US$) in Timor-Leste in 2002 to that in 2004?
Provide a short and direct response. 0.97. What is the ratio of the Value added (constant 2005 US$) of Latin America(all income levels) in 2002 to that in 2005?
Keep it short and to the point. 0.89. What is the ratio of the Value added (constant 2005 US$) of Mauritius in 2002 to that in 2005?
Offer a very short reply. 0.84. What is the ratio of the Value added (constant 2005 US$) of Nicaragua in 2002 to that in 2005?
Offer a very short reply. 0.91. What is the ratio of the Value added (constant 2005 US$) in Timor-Leste in 2002 to that in 2005?
Your answer should be compact. 0.89. What is the ratio of the Value added (constant 2005 US$) in Latin America(all income levels) in 2002 to that in 2006?
Make the answer very short. 0.84. What is the ratio of the Value added (constant 2005 US$) of Mauritius in 2002 to that in 2006?
Provide a succinct answer. 0.8. What is the ratio of the Value added (constant 2005 US$) of Nicaragua in 2002 to that in 2006?
Keep it short and to the point. 0.8. What is the ratio of the Value added (constant 2005 US$) of Timor-Leste in 2002 to that in 2006?
Provide a succinct answer. 0.92. What is the ratio of the Value added (constant 2005 US$) of Latin America(all income levels) in 2003 to that in 2004?
Offer a very short reply. 0.95. What is the ratio of the Value added (constant 2005 US$) of Mauritius in 2003 to that in 2004?
Offer a very short reply. 0.94. What is the ratio of the Value added (constant 2005 US$) of Nicaragua in 2003 to that in 2004?
Your answer should be very brief. 0.97. What is the ratio of the Value added (constant 2005 US$) of Timor-Leste in 2003 to that in 2004?
Offer a terse response. 0.96. What is the ratio of the Value added (constant 2005 US$) in Latin America(all income levels) in 2003 to that in 2005?
Your answer should be compact. 0.91. What is the ratio of the Value added (constant 2005 US$) in Mauritius in 2003 to that in 2005?
Provide a succinct answer. 0.88. What is the ratio of the Value added (constant 2005 US$) of Nicaragua in 2003 to that in 2005?
Provide a short and direct response. 0.94. What is the ratio of the Value added (constant 2005 US$) in Timor-Leste in 2003 to that in 2005?
Your response must be concise. 0.88. What is the ratio of the Value added (constant 2005 US$) in Latin America(all income levels) in 2003 to that in 2006?
Make the answer very short. 0.86. What is the ratio of the Value added (constant 2005 US$) of Mauritius in 2003 to that in 2006?
Ensure brevity in your answer.  0.84. What is the ratio of the Value added (constant 2005 US$) of Nicaragua in 2003 to that in 2006?
Give a very brief answer. 0.82. What is the ratio of the Value added (constant 2005 US$) in Timor-Leste in 2003 to that in 2006?
Your response must be concise. 0.91. What is the ratio of the Value added (constant 2005 US$) of Latin America(all income levels) in 2004 to that in 2005?
Provide a succinct answer. 0.95. What is the ratio of the Value added (constant 2005 US$) in Mauritius in 2004 to that in 2005?
Your response must be concise. 0.94. What is the ratio of the Value added (constant 2005 US$) in Nicaragua in 2004 to that in 2005?
Your response must be concise. 0.96. What is the ratio of the Value added (constant 2005 US$) in Timor-Leste in 2004 to that in 2005?
Ensure brevity in your answer.  0.92. What is the ratio of the Value added (constant 2005 US$) in Latin America(all income levels) in 2004 to that in 2006?
Make the answer very short. 0.91. What is the ratio of the Value added (constant 2005 US$) of Mauritius in 2004 to that in 2006?
Your response must be concise. 0.89. What is the ratio of the Value added (constant 2005 US$) of Nicaragua in 2004 to that in 2006?
Your answer should be very brief. 0.85. What is the ratio of the Value added (constant 2005 US$) in Timor-Leste in 2004 to that in 2006?
Make the answer very short. 0.94. What is the ratio of the Value added (constant 2005 US$) in Latin America(all income levels) in 2005 to that in 2006?
Your answer should be very brief. 0.95. What is the ratio of the Value added (constant 2005 US$) of Mauritius in 2005 to that in 2006?
Your answer should be compact. 0.95. What is the ratio of the Value added (constant 2005 US$) in Nicaragua in 2005 to that in 2006?
Your answer should be very brief. 0.88. What is the ratio of the Value added (constant 2005 US$) of Timor-Leste in 2005 to that in 2006?
Your answer should be very brief. 1.03. What is the difference between the highest and the second highest Value added (constant 2005 US$) in Latin America(all income levels)?
Your answer should be compact. 8.31e+1. What is the difference between the highest and the second highest Value added (constant 2005 US$) of Mauritius?
Provide a succinct answer. 2.06e+08. What is the difference between the highest and the second highest Value added (constant 2005 US$) in Nicaragua?
Provide a short and direct response. 4.34e+08. What is the difference between the highest and the second highest Value added (constant 2005 US$) of Timor-Leste?
Your response must be concise. 1.53e+06. What is the difference between the highest and the lowest Value added (constant 2005 US$) of Latin America(all income levels)?
Your answer should be very brief. 2.90e+11. What is the difference between the highest and the lowest Value added (constant 2005 US$) of Mauritius?
Ensure brevity in your answer.  1.09e+09. What is the difference between the highest and the lowest Value added (constant 2005 US$) of Nicaragua?
Ensure brevity in your answer.  8.97e+08. What is the difference between the highest and the lowest Value added (constant 2005 US$) in Timor-Leste?
Keep it short and to the point. 7.10e+07. 